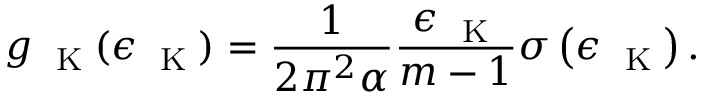Convert formula to latex. <formula><loc_0><loc_0><loc_500><loc_500>g _ { K } ( \epsilon _ { K } ) = \frac { 1 } { 2 \pi ^ { 2 } \alpha } \frac { \epsilon _ { K } } { m - 1 } \sigma \left ( { \epsilon _ { K } } \right ) .</formula> 